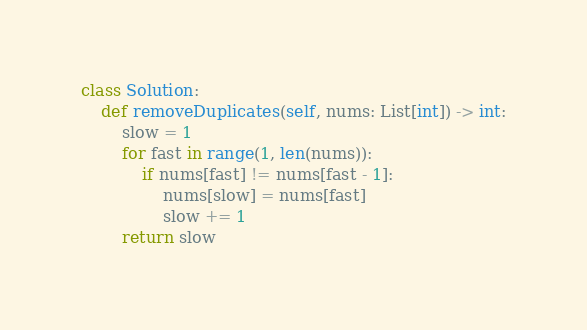Convert code to text. <code><loc_0><loc_0><loc_500><loc_500><_Python_>class Solution:
    def removeDuplicates(self, nums: List[int]) -> int:
        slow = 1
        for fast in range(1, len(nums)):
            if nums[fast] != nums[fast - 1]:
                nums[slow] = nums[fast]
                slow += 1
        return slow

</code> 